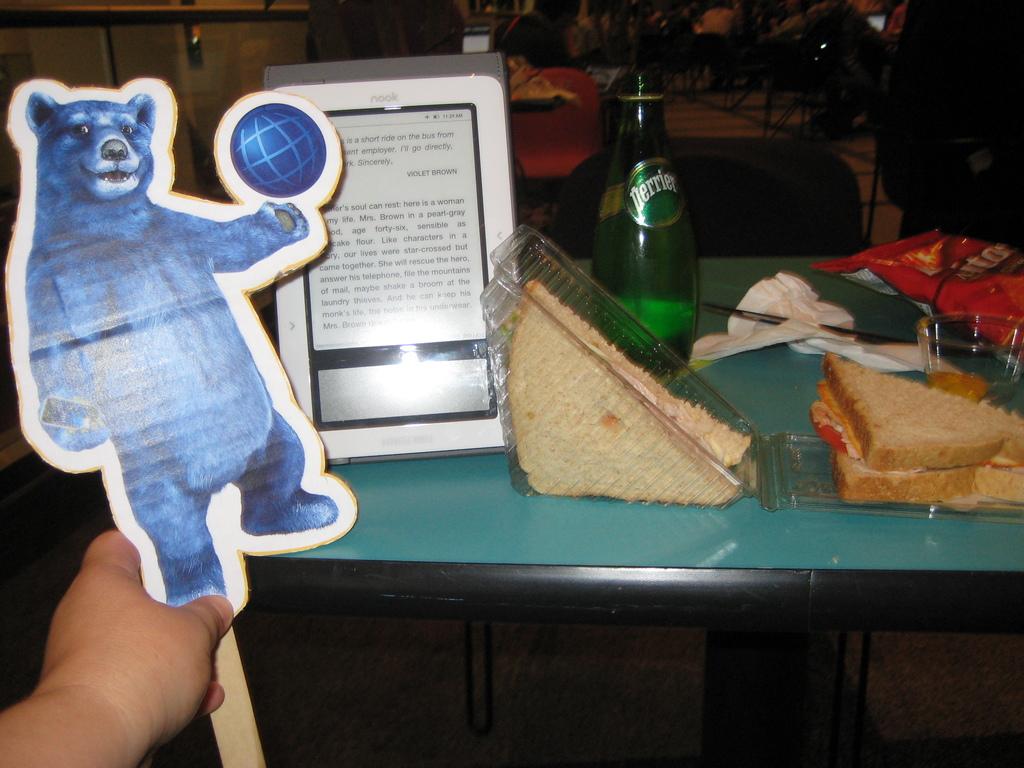What brand is on the green bottle?
Your answer should be compact. Perrier. 